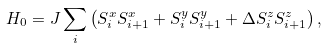<formula> <loc_0><loc_0><loc_500><loc_500>H _ { 0 } = J \sum _ { i } \left ( S ^ { x } _ { i } S ^ { x } _ { i + 1 } + S ^ { y } _ { i } S ^ { y } _ { i + 1 } + \Delta S ^ { z } _ { i } S ^ { z } _ { i + 1 } \right ) ,</formula> 